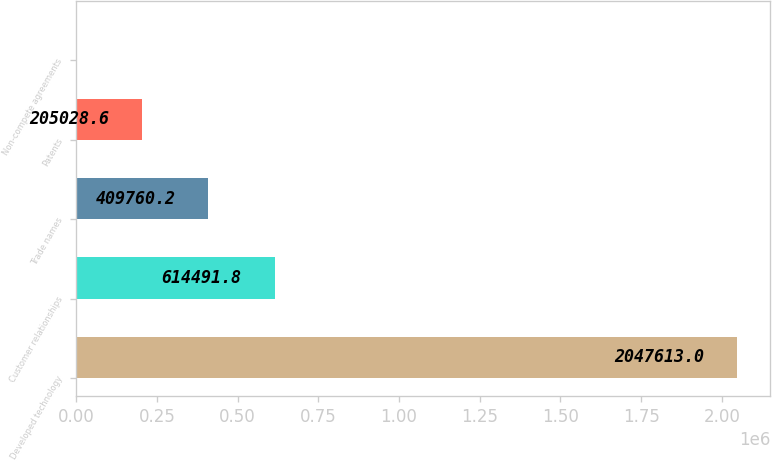Convert chart to OTSL. <chart><loc_0><loc_0><loc_500><loc_500><bar_chart><fcel>Developed technology<fcel>Customer relationships<fcel>Trade names<fcel>Patents<fcel>Non-compete agreements<nl><fcel>2.04761e+06<fcel>614492<fcel>409760<fcel>205029<fcel>297<nl></chart> 